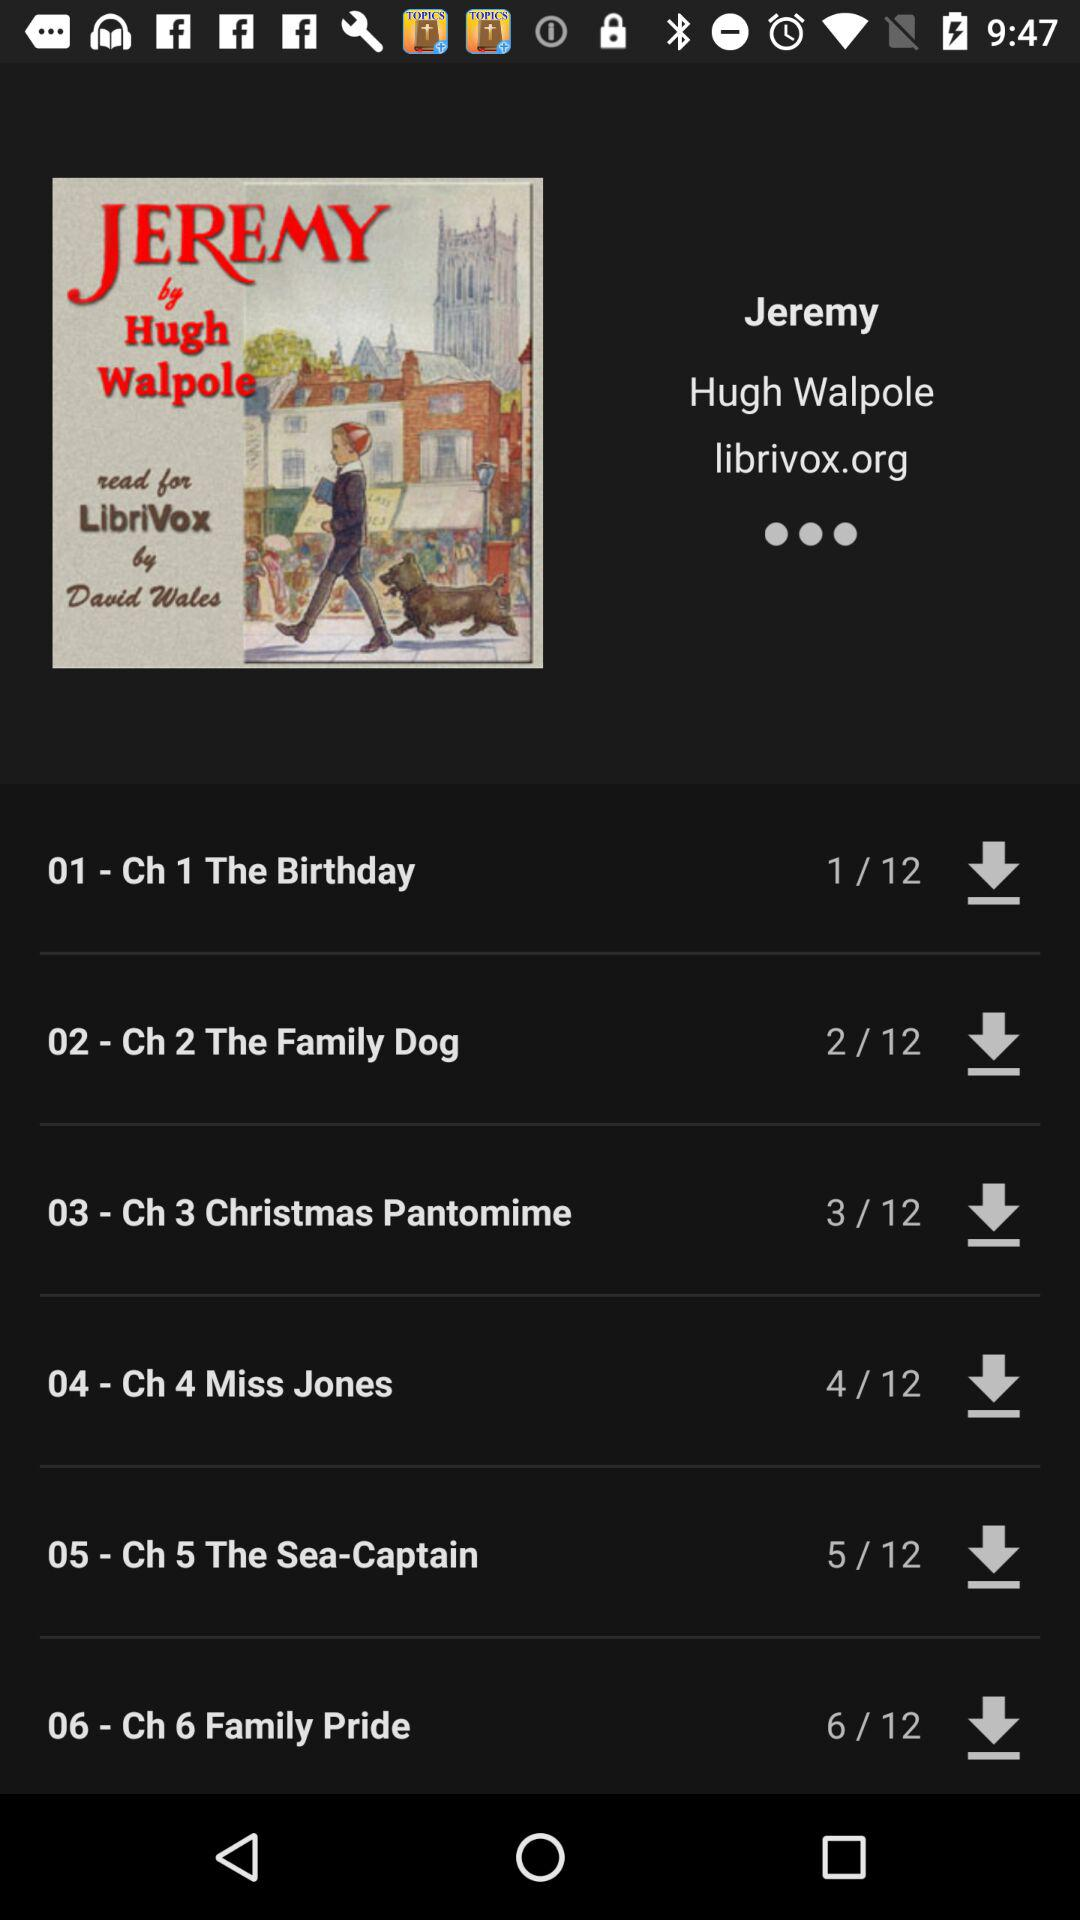What is the book name? The book's name is "Jeremy". 